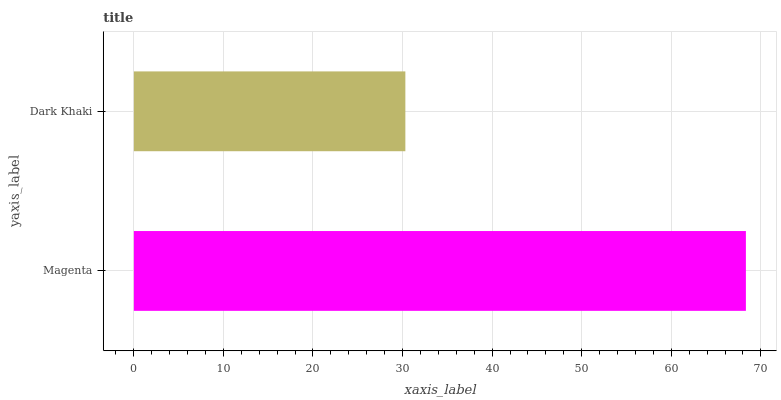Is Dark Khaki the minimum?
Answer yes or no. Yes. Is Magenta the maximum?
Answer yes or no. Yes. Is Dark Khaki the maximum?
Answer yes or no. No. Is Magenta greater than Dark Khaki?
Answer yes or no. Yes. Is Dark Khaki less than Magenta?
Answer yes or no. Yes. Is Dark Khaki greater than Magenta?
Answer yes or no. No. Is Magenta less than Dark Khaki?
Answer yes or no. No. Is Magenta the high median?
Answer yes or no. Yes. Is Dark Khaki the low median?
Answer yes or no. Yes. Is Dark Khaki the high median?
Answer yes or no. No. Is Magenta the low median?
Answer yes or no. No. 